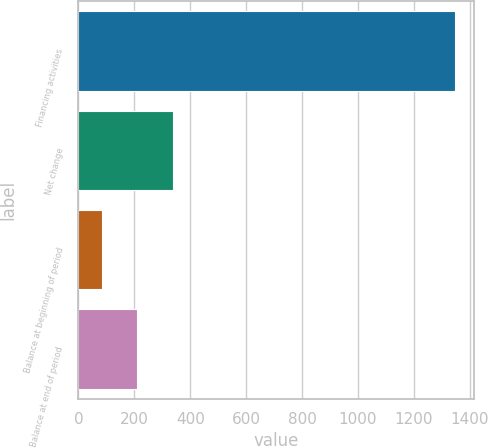<chart> <loc_0><loc_0><loc_500><loc_500><bar_chart><fcel>Financing activities<fcel>Net change<fcel>Balance at beginning of period<fcel>Balance at end of period<nl><fcel>1348<fcel>336.8<fcel>84<fcel>210.4<nl></chart> 